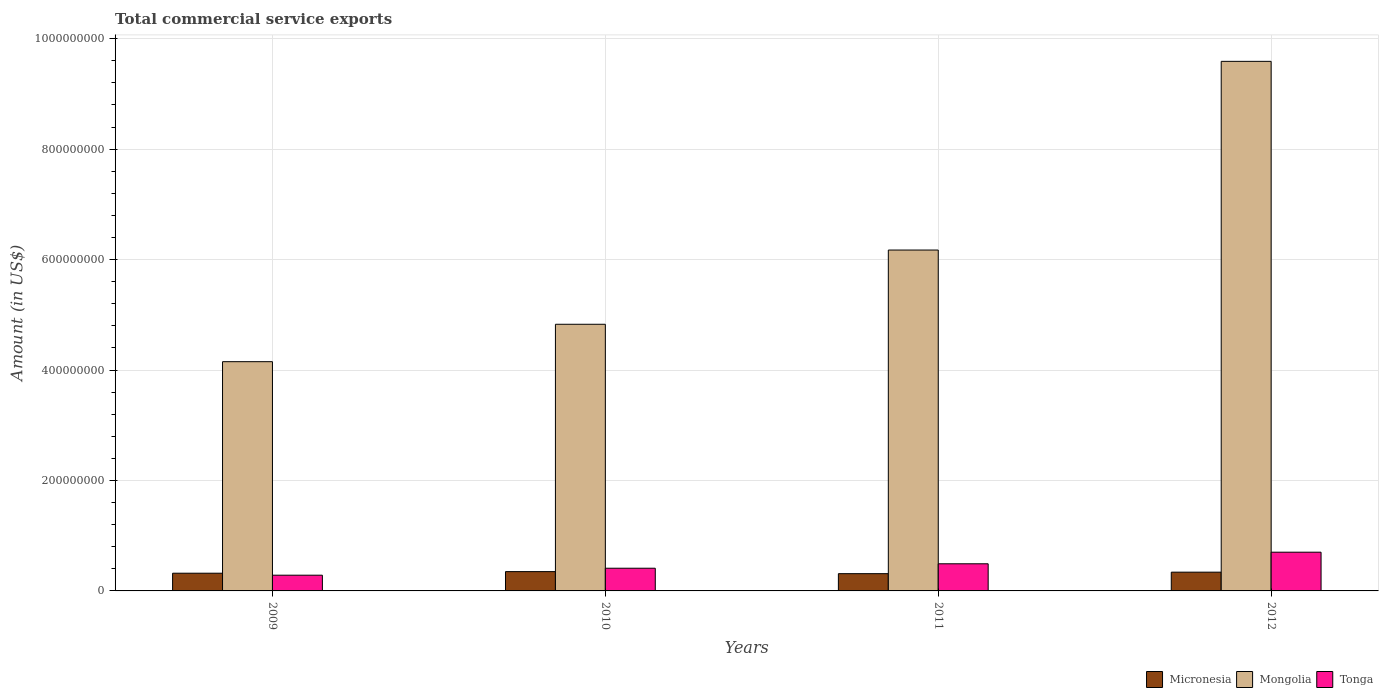Are the number of bars per tick equal to the number of legend labels?
Your answer should be very brief. Yes. How many bars are there on the 3rd tick from the left?
Provide a short and direct response. 3. How many bars are there on the 1st tick from the right?
Your response must be concise. 3. What is the label of the 4th group of bars from the left?
Give a very brief answer. 2012. What is the total commercial service exports in Micronesia in 2009?
Give a very brief answer. 3.21e+07. Across all years, what is the maximum total commercial service exports in Tonga?
Provide a short and direct response. 7.01e+07. Across all years, what is the minimum total commercial service exports in Tonga?
Keep it short and to the point. 2.85e+07. What is the total total commercial service exports in Micronesia in the graph?
Your response must be concise. 1.32e+08. What is the difference between the total commercial service exports in Tonga in 2009 and that in 2011?
Ensure brevity in your answer.  -2.07e+07. What is the difference between the total commercial service exports in Micronesia in 2011 and the total commercial service exports in Mongolia in 2009?
Your answer should be compact. -3.84e+08. What is the average total commercial service exports in Mongolia per year?
Your response must be concise. 6.19e+08. In the year 2012, what is the difference between the total commercial service exports in Tonga and total commercial service exports in Micronesia?
Give a very brief answer. 3.62e+07. What is the ratio of the total commercial service exports in Tonga in 2009 to that in 2010?
Keep it short and to the point. 0.69. What is the difference between the highest and the second highest total commercial service exports in Micronesia?
Your response must be concise. 9.99e+05. What is the difference between the highest and the lowest total commercial service exports in Tonga?
Your response must be concise. 4.17e+07. In how many years, is the total commercial service exports in Tonga greater than the average total commercial service exports in Tonga taken over all years?
Offer a very short reply. 2. What does the 2nd bar from the left in 2012 represents?
Provide a short and direct response. Mongolia. What does the 1st bar from the right in 2009 represents?
Keep it short and to the point. Tonga. What is the difference between two consecutive major ticks on the Y-axis?
Provide a short and direct response. 2.00e+08. Are the values on the major ticks of Y-axis written in scientific E-notation?
Make the answer very short. No. Does the graph contain grids?
Keep it short and to the point. Yes. How many legend labels are there?
Give a very brief answer. 3. How are the legend labels stacked?
Provide a succinct answer. Horizontal. What is the title of the graph?
Your answer should be very brief. Total commercial service exports. What is the label or title of the X-axis?
Give a very brief answer. Years. What is the label or title of the Y-axis?
Provide a succinct answer. Amount (in US$). What is the Amount (in US$) of Micronesia in 2009?
Offer a very short reply. 3.21e+07. What is the Amount (in US$) of Mongolia in 2009?
Your response must be concise. 4.15e+08. What is the Amount (in US$) in Tonga in 2009?
Your answer should be compact. 2.85e+07. What is the Amount (in US$) in Micronesia in 2010?
Ensure brevity in your answer.  3.50e+07. What is the Amount (in US$) in Mongolia in 2010?
Provide a succinct answer. 4.83e+08. What is the Amount (in US$) in Tonga in 2010?
Give a very brief answer. 4.11e+07. What is the Amount (in US$) in Micronesia in 2011?
Your answer should be very brief. 3.13e+07. What is the Amount (in US$) of Mongolia in 2011?
Keep it short and to the point. 6.17e+08. What is the Amount (in US$) of Tonga in 2011?
Offer a very short reply. 4.91e+07. What is the Amount (in US$) in Micronesia in 2012?
Keep it short and to the point. 3.40e+07. What is the Amount (in US$) of Mongolia in 2012?
Keep it short and to the point. 9.59e+08. What is the Amount (in US$) of Tonga in 2012?
Your answer should be very brief. 7.01e+07. Across all years, what is the maximum Amount (in US$) in Micronesia?
Your answer should be very brief. 3.50e+07. Across all years, what is the maximum Amount (in US$) in Mongolia?
Give a very brief answer. 9.59e+08. Across all years, what is the maximum Amount (in US$) in Tonga?
Ensure brevity in your answer.  7.01e+07. Across all years, what is the minimum Amount (in US$) of Micronesia?
Make the answer very short. 3.13e+07. Across all years, what is the minimum Amount (in US$) of Mongolia?
Offer a very short reply. 4.15e+08. Across all years, what is the minimum Amount (in US$) of Tonga?
Ensure brevity in your answer.  2.85e+07. What is the total Amount (in US$) in Micronesia in the graph?
Provide a short and direct response. 1.32e+08. What is the total Amount (in US$) in Mongolia in the graph?
Offer a terse response. 2.47e+09. What is the total Amount (in US$) of Tonga in the graph?
Offer a very short reply. 1.89e+08. What is the difference between the Amount (in US$) of Micronesia in 2009 and that in 2010?
Provide a succinct answer. -2.88e+06. What is the difference between the Amount (in US$) in Mongolia in 2009 and that in 2010?
Offer a very short reply. -6.77e+07. What is the difference between the Amount (in US$) of Tonga in 2009 and that in 2010?
Your answer should be very brief. -1.26e+07. What is the difference between the Amount (in US$) in Micronesia in 2009 and that in 2011?
Your response must be concise. 8.24e+05. What is the difference between the Amount (in US$) in Mongolia in 2009 and that in 2011?
Ensure brevity in your answer.  -2.02e+08. What is the difference between the Amount (in US$) in Tonga in 2009 and that in 2011?
Offer a terse response. -2.07e+07. What is the difference between the Amount (in US$) in Micronesia in 2009 and that in 2012?
Your response must be concise. -1.88e+06. What is the difference between the Amount (in US$) of Mongolia in 2009 and that in 2012?
Provide a short and direct response. -5.44e+08. What is the difference between the Amount (in US$) in Tonga in 2009 and that in 2012?
Provide a short and direct response. -4.17e+07. What is the difference between the Amount (in US$) in Micronesia in 2010 and that in 2011?
Your response must be concise. 3.70e+06. What is the difference between the Amount (in US$) of Mongolia in 2010 and that in 2011?
Keep it short and to the point. -1.34e+08. What is the difference between the Amount (in US$) of Tonga in 2010 and that in 2011?
Offer a very short reply. -8.03e+06. What is the difference between the Amount (in US$) in Micronesia in 2010 and that in 2012?
Offer a very short reply. 9.99e+05. What is the difference between the Amount (in US$) of Mongolia in 2010 and that in 2012?
Offer a very short reply. -4.76e+08. What is the difference between the Amount (in US$) of Tonga in 2010 and that in 2012?
Your answer should be very brief. -2.90e+07. What is the difference between the Amount (in US$) in Micronesia in 2011 and that in 2012?
Provide a succinct answer. -2.70e+06. What is the difference between the Amount (in US$) of Mongolia in 2011 and that in 2012?
Provide a succinct answer. -3.42e+08. What is the difference between the Amount (in US$) of Tonga in 2011 and that in 2012?
Offer a terse response. -2.10e+07. What is the difference between the Amount (in US$) of Micronesia in 2009 and the Amount (in US$) of Mongolia in 2010?
Offer a terse response. -4.51e+08. What is the difference between the Amount (in US$) of Micronesia in 2009 and the Amount (in US$) of Tonga in 2010?
Your answer should be compact. -9.01e+06. What is the difference between the Amount (in US$) of Mongolia in 2009 and the Amount (in US$) of Tonga in 2010?
Keep it short and to the point. 3.74e+08. What is the difference between the Amount (in US$) of Micronesia in 2009 and the Amount (in US$) of Mongolia in 2011?
Ensure brevity in your answer.  -5.85e+08. What is the difference between the Amount (in US$) of Micronesia in 2009 and the Amount (in US$) of Tonga in 2011?
Your answer should be very brief. -1.70e+07. What is the difference between the Amount (in US$) in Mongolia in 2009 and the Amount (in US$) in Tonga in 2011?
Your answer should be compact. 3.66e+08. What is the difference between the Amount (in US$) in Micronesia in 2009 and the Amount (in US$) in Mongolia in 2012?
Provide a succinct answer. -9.27e+08. What is the difference between the Amount (in US$) of Micronesia in 2009 and the Amount (in US$) of Tonga in 2012?
Keep it short and to the point. -3.80e+07. What is the difference between the Amount (in US$) of Mongolia in 2009 and the Amount (in US$) of Tonga in 2012?
Your answer should be very brief. 3.45e+08. What is the difference between the Amount (in US$) of Micronesia in 2010 and the Amount (in US$) of Mongolia in 2011?
Ensure brevity in your answer.  -5.82e+08. What is the difference between the Amount (in US$) of Micronesia in 2010 and the Amount (in US$) of Tonga in 2011?
Offer a terse response. -1.42e+07. What is the difference between the Amount (in US$) in Mongolia in 2010 and the Amount (in US$) in Tonga in 2011?
Provide a succinct answer. 4.34e+08. What is the difference between the Amount (in US$) of Micronesia in 2010 and the Amount (in US$) of Mongolia in 2012?
Provide a short and direct response. -9.24e+08. What is the difference between the Amount (in US$) of Micronesia in 2010 and the Amount (in US$) of Tonga in 2012?
Offer a very short reply. -3.52e+07. What is the difference between the Amount (in US$) in Mongolia in 2010 and the Amount (in US$) in Tonga in 2012?
Make the answer very short. 4.13e+08. What is the difference between the Amount (in US$) in Micronesia in 2011 and the Amount (in US$) in Mongolia in 2012?
Provide a short and direct response. -9.28e+08. What is the difference between the Amount (in US$) of Micronesia in 2011 and the Amount (in US$) of Tonga in 2012?
Offer a terse response. -3.89e+07. What is the difference between the Amount (in US$) of Mongolia in 2011 and the Amount (in US$) of Tonga in 2012?
Your answer should be compact. 5.47e+08. What is the average Amount (in US$) in Micronesia per year?
Your answer should be compact. 3.31e+07. What is the average Amount (in US$) of Mongolia per year?
Keep it short and to the point. 6.19e+08. What is the average Amount (in US$) in Tonga per year?
Ensure brevity in your answer.  4.72e+07. In the year 2009, what is the difference between the Amount (in US$) in Micronesia and Amount (in US$) in Mongolia?
Provide a short and direct response. -3.83e+08. In the year 2009, what is the difference between the Amount (in US$) in Micronesia and Amount (in US$) in Tonga?
Offer a very short reply. 3.62e+06. In the year 2009, what is the difference between the Amount (in US$) in Mongolia and Amount (in US$) in Tonga?
Your response must be concise. 3.87e+08. In the year 2010, what is the difference between the Amount (in US$) in Micronesia and Amount (in US$) in Mongolia?
Your response must be concise. -4.48e+08. In the year 2010, what is the difference between the Amount (in US$) in Micronesia and Amount (in US$) in Tonga?
Give a very brief answer. -6.13e+06. In the year 2010, what is the difference between the Amount (in US$) of Mongolia and Amount (in US$) of Tonga?
Give a very brief answer. 4.42e+08. In the year 2011, what is the difference between the Amount (in US$) in Micronesia and Amount (in US$) in Mongolia?
Provide a succinct answer. -5.86e+08. In the year 2011, what is the difference between the Amount (in US$) of Micronesia and Amount (in US$) of Tonga?
Give a very brief answer. -1.79e+07. In the year 2011, what is the difference between the Amount (in US$) of Mongolia and Amount (in US$) of Tonga?
Make the answer very short. 5.68e+08. In the year 2012, what is the difference between the Amount (in US$) of Micronesia and Amount (in US$) of Mongolia?
Offer a terse response. -9.25e+08. In the year 2012, what is the difference between the Amount (in US$) of Micronesia and Amount (in US$) of Tonga?
Offer a terse response. -3.62e+07. In the year 2012, what is the difference between the Amount (in US$) of Mongolia and Amount (in US$) of Tonga?
Your response must be concise. 8.89e+08. What is the ratio of the Amount (in US$) of Micronesia in 2009 to that in 2010?
Keep it short and to the point. 0.92. What is the ratio of the Amount (in US$) in Mongolia in 2009 to that in 2010?
Make the answer very short. 0.86. What is the ratio of the Amount (in US$) in Tonga in 2009 to that in 2010?
Make the answer very short. 0.69. What is the ratio of the Amount (in US$) of Micronesia in 2009 to that in 2011?
Your answer should be very brief. 1.03. What is the ratio of the Amount (in US$) in Mongolia in 2009 to that in 2011?
Offer a terse response. 0.67. What is the ratio of the Amount (in US$) in Tonga in 2009 to that in 2011?
Offer a very short reply. 0.58. What is the ratio of the Amount (in US$) in Micronesia in 2009 to that in 2012?
Your answer should be compact. 0.94. What is the ratio of the Amount (in US$) of Mongolia in 2009 to that in 2012?
Offer a terse response. 0.43. What is the ratio of the Amount (in US$) of Tonga in 2009 to that in 2012?
Provide a succinct answer. 0.41. What is the ratio of the Amount (in US$) of Micronesia in 2010 to that in 2011?
Offer a very short reply. 1.12. What is the ratio of the Amount (in US$) of Mongolia in 2010 to that in 2011?
Your answer should be compact. 0.78. What is the ratio of the Amount (in US$) of Tonga in 2010 to that in 2011?
Make the answer very short. 0.84. What is the ratio of the Amount (in US$) of Micronesia in 2010 to that in 2012?
Provide a succinct answer. 1.03. What is the ratio of the Amount (in US$) of Mongolia in 2010 to that in 2012?
Offer a very short reply. 0.5. What is the ratio of the Amount (in US$) of Tonga in 2010 to that in 2012?
Offer a very short reply. 0.59. What is the ratio of the Amount (in US$) of Micronesia in 2011 to that in 2012?
Offer a very short reply. 0.92. What is the ratio of the Amount (in US$) of Mongolia in 2011 to that in 2012?
Provide a succinct answer. 0.64. What is the ratio of the Amount (in US$) in Tonga in 2011 to that in 2012?
Offer a very short reply. 0.7. What is the difference between the highest and the second highest Amount (in US$) of Micronesia?
Your answer should be very brief. 9.99e+05. What is the difference between the highest and the second highest Amount (in US$) of Mongolia?
Ensure brevity in your answer.  3.42e+08. What is the difference between the highest and the second highest Amount (in US$) in Tonga?
Provide a succinct answer. 2.10e+07. What is the difference between the highest and the lowest Amount (in US$) of Micronesia?
Provide a succinct answer. 3.70e+06. What is the difference between the highest and the lowest Amount (in US$) of Mongolia?
Ensure brevity in your answer.  5.44e+08. What is the difference between the highest and the lowest Amount (in US$) in Tonga?
Your answer should be compact. 4.17e+07. 